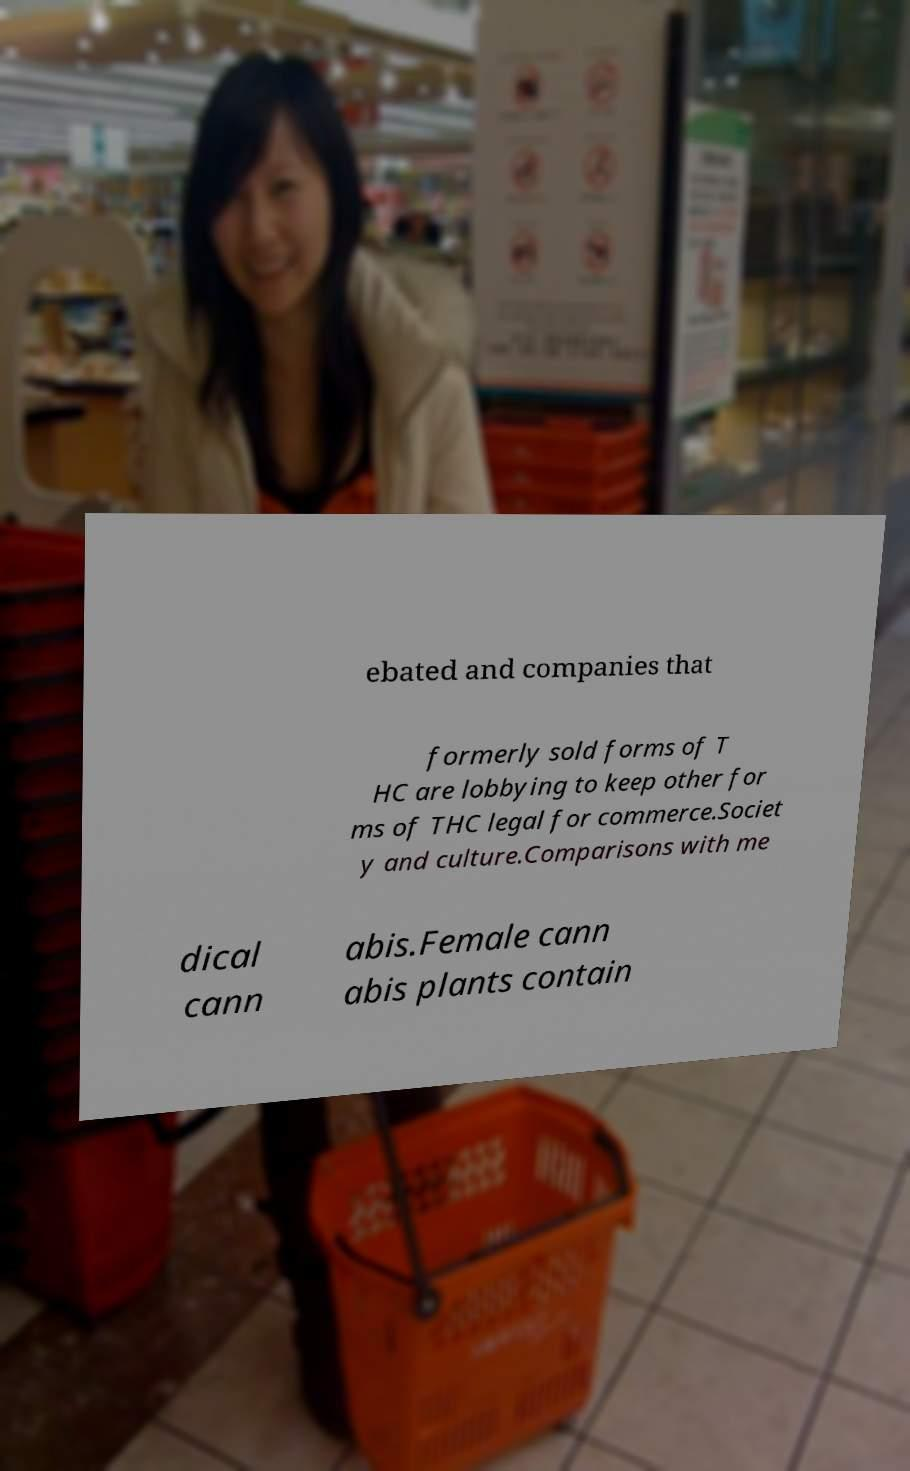There's text embedded in this image that I need extracted. Can you transcribe it verbatim? ebated and companies that formerly sold forms of T HC are lobbying to keep other for ms of THC legal for commerce.Societ y and culture.Comparisons with me dical cann abis.Female cann abis plants contain 